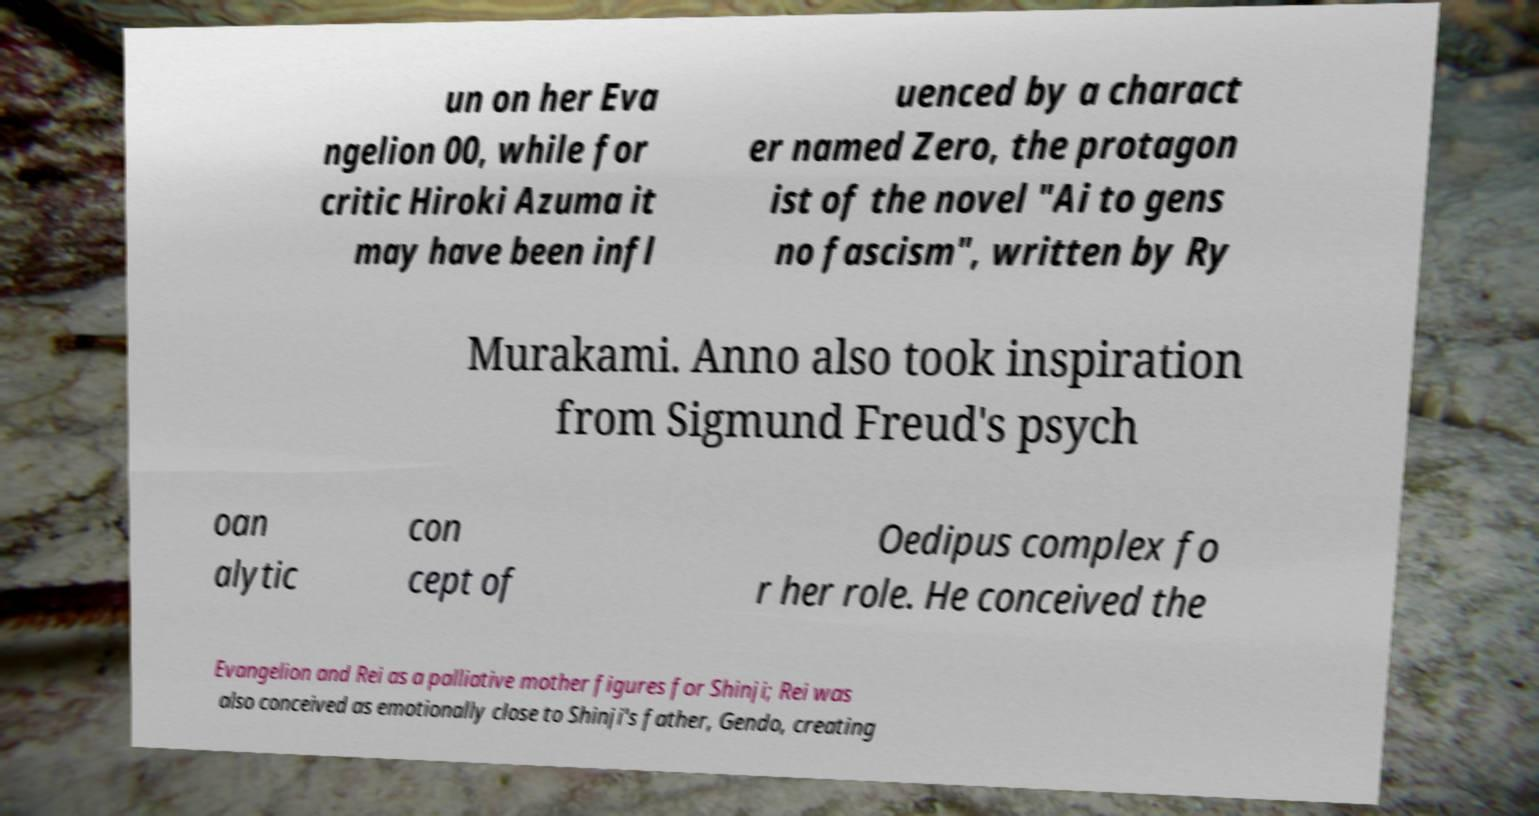I need the written content from this picture converted into text. Can you do that? un on her Eva ngelion 00, while for critic Hiroki Azuma it may have been infl uenced by a charact er named Zero, the protagon ist of the novel "Ai to gens no fascism", written by Ry Murakami. Anno also took inspiration from Sigmund Freud's psych oan alytic con cept of Oedipus complex fo r her role. He conceived the Evangelion and Rei as a palliative mother figures for Shinji; Rei was also conceived as emotionally close to Shinji's father, Gendo, creating 